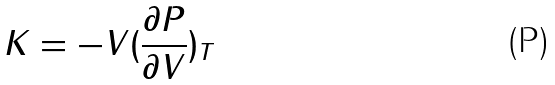Convert formula to latex. <formula><loc_0><loc_0><loc_500><loc_500>K = - V ( \frac { \partial P } { \partial V } ) _ { T }</formula> 